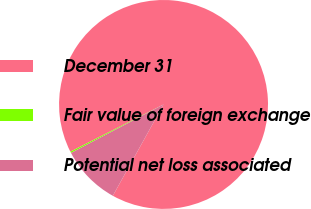Convert chart to OTSL. <chart><loc_0><loc_0><loc_500><loc_500><pie_chart><fcel>December 31<fcel>Fair value of foreign exchange<fcel>Potential net loss associated<nl><fcel>90.54%<fcel>0.22%<fcel>9.25%<nl></chart> 